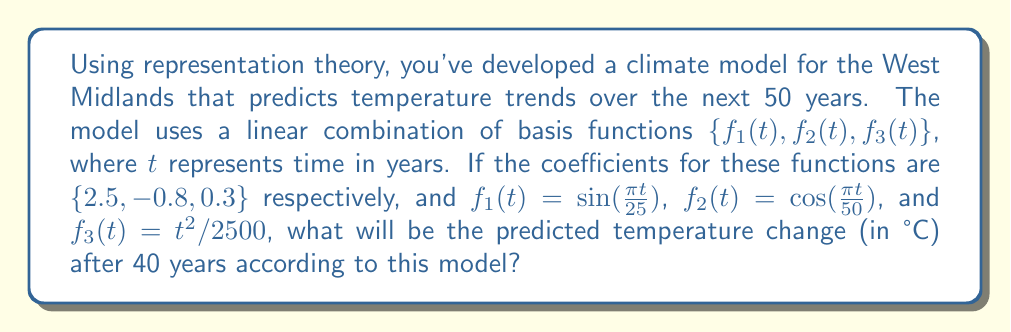Provide a solution to this math problem. To solve this problem, we'll follow these steps:

1) The general form of our climate model is:

   $$T(t) = 2.5f_1(t) - 0.8f_2(t) + 0.3f_3(t)$$

2) We need to calculate each term for $t = 40$:

   For $f_1(t)$:
   $$f_1(40) = \sin(\frac{\pi \cdot 40}{25}) = \sin(1.6\pi) \approx -0.9511$$

   For $f_2(t)$:
   $$f_2(40) = \cos(\frac{\pi \cdot 40}{50}) = \cos(0.8\pi) \approx -0.8090$$

   For $f_3(t)$:
   $$f_3(40) = \frac{40^2}{2500} = \frac{1600}{2500} = 0.64$$

3) Now, we can substitute these values into our model:

   $$T(40) = 2.5(-0.9511) - 0.8(-0.8090) + 0.3(0.64)$$

4) Let's calculate each term:

   $$2.5(-0.9511) = -2.3778$$
   $$-0.8(-0.8090) = 0.6472$$
   $$0.3(0.64) = 0.1920$$

5) Finally, we sum these terms:

   $$T(40) = -2.3778 + 0.6472 + 0.1920 = -1.5386$$

Therefore, the predicted temperature change after 40 years is approximately -1.5386°C.
Answer: -1.54°C 